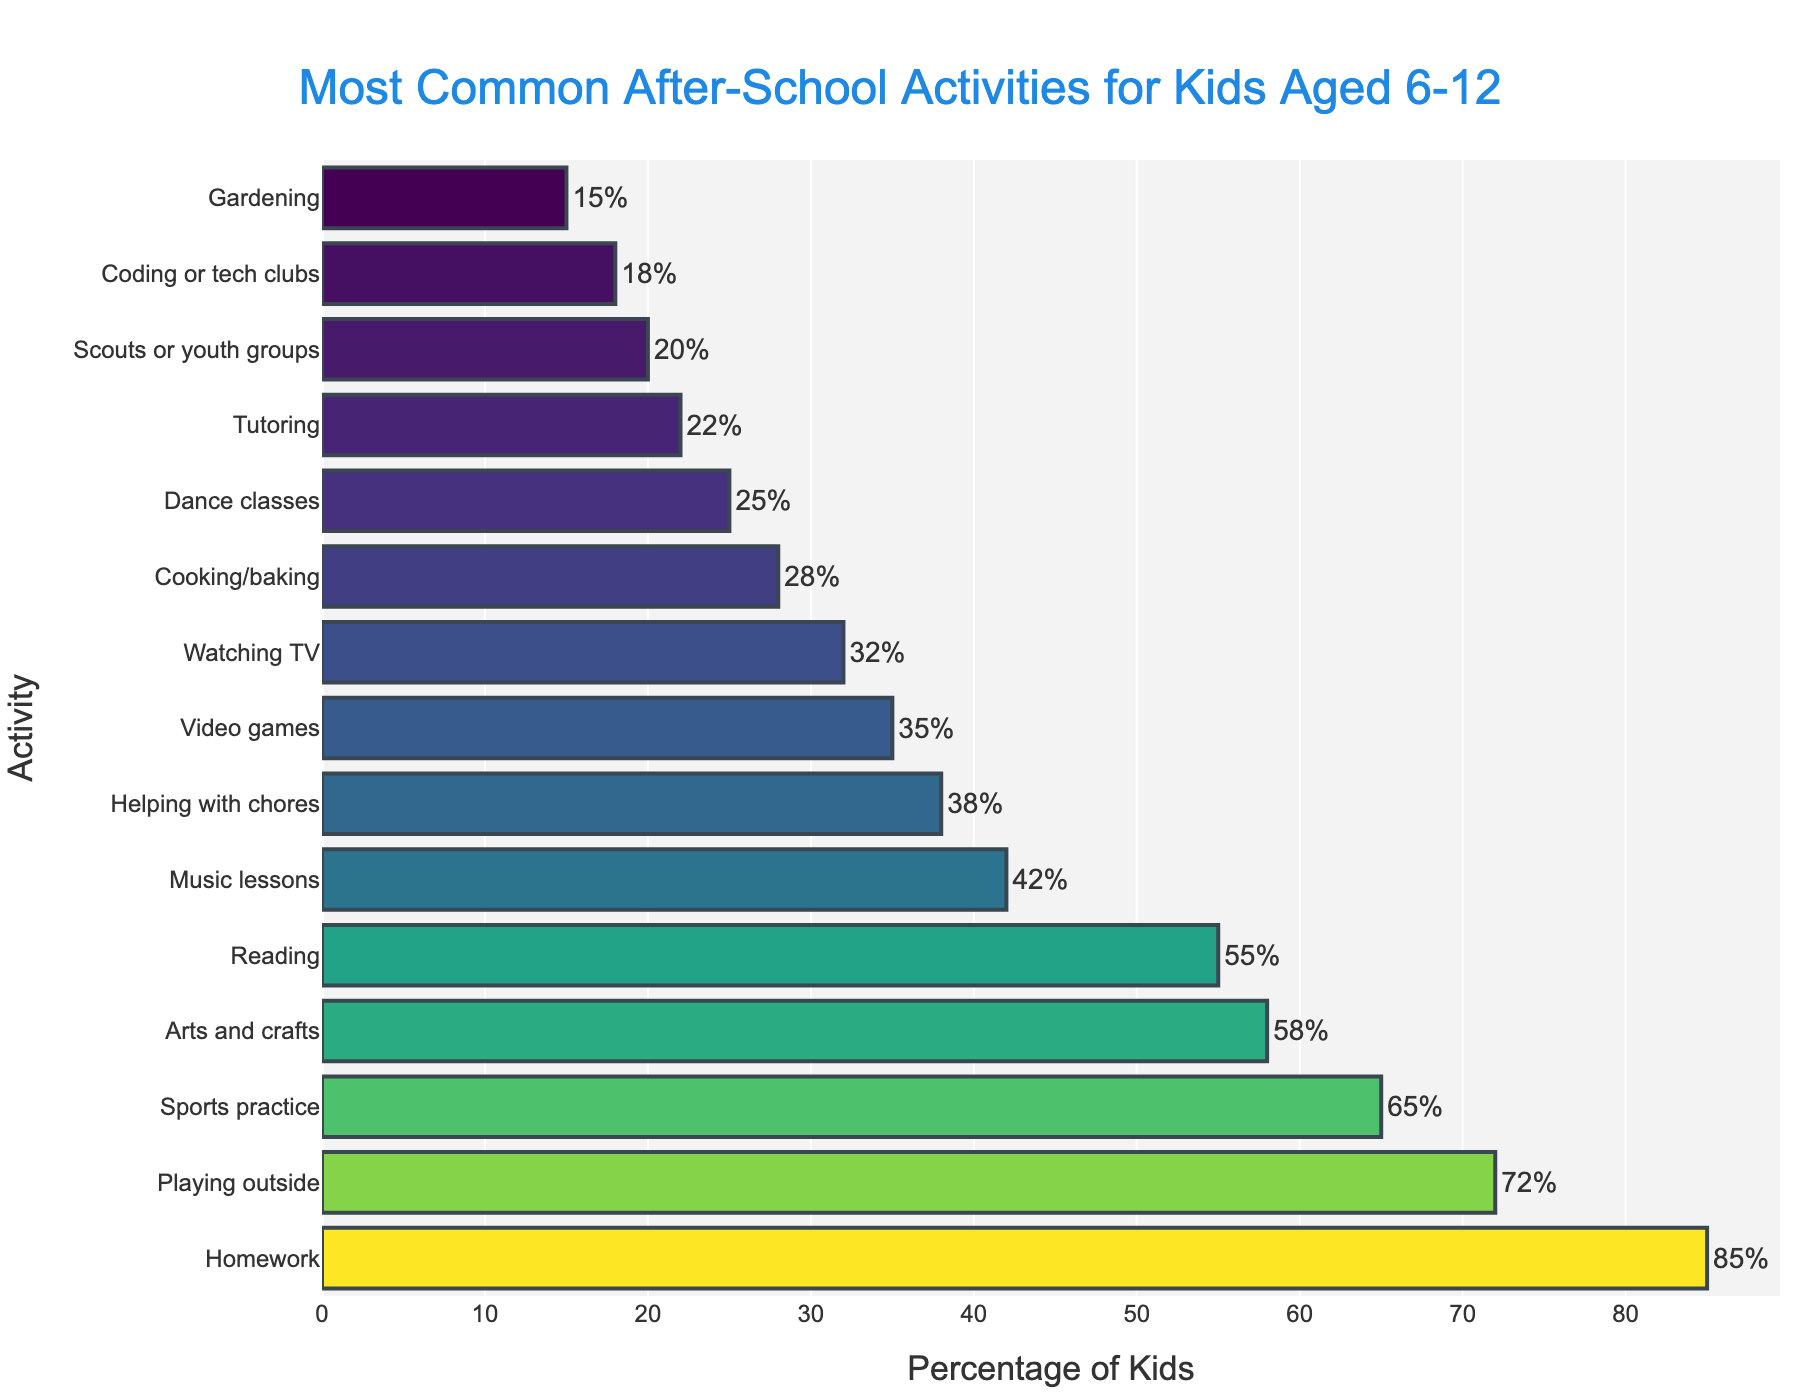What is the most common after-school activity for kids aged 6-12? Looking at the bar chart, the longest bar represents the most common activity. "Homework" has the longest bar with 85% participation.
Answer: Homework Which activity is more common, reading or music lessons? Compare the lengths of the bars for reading and music lessons. Reading has a bar with 55%, while music lessons have a bar with 42%. So, reading is more common.
Answer: Reading What is the difference in percentage between kids who play outside and those who play video games? Find the percentages for both activities: playing outside (72%) and video games (35%). Subtract video games from playing outside (72% - 35% = 37%).
Answer: 37% What is the total percentage of kids participating in gardening and scouts or youth groups combined? Identify the percentages for gardening (15%) and scouts or youth groups (20%). Add them together (15% + 20% = 35%).
Answer: 35% How many more kids help with chores compared to those who are in dance classes? Locate the percentages for both activities: helping with chores (38%) and dance classes (25%). Subtract the percentage for dance classes from that of helping with chores (38% - 25% = 13%).
Answer: 13% Which activities have less than 30% participation? Look at the bars with percentages lower than 30%: Cooking/baking (28%), Dance classes (25%), Tutoring (22%), Scouts or youth groups (20%), Coding or tech clubs (18%), and Gardening (15%).
Answer: Cooking/baking, Dance classes, Tutoring, Scouts or youth groups, Coding or tech clubs, Gardening By how much does participation in arts and crafts exceed that in cooking/baking? Identify the percentages for arts and crafts (58%) and cooking/baking (28%). Subtract cooking/baking from arts and crafts (58% - 28% = 30%).
Answer: 30% What is the average participation percentage for the three most common activities? Find the percentages for the three most common activities: Homework (85%), Playing outside (72%), and Sports practice (65%). Calculate the average: (85% + 72% + 65%) / 3 = 74%.
Answer: 74% What is the ratio of kids participating in sports practice to those participating in tutoring? Identify the percentages for sports practice (65%) and tutoring (22%). Divide the percentage for sports practice by that for tutoring (65% / 22% ≈ 2.95).
Answer: 2.95 What is the median percentage of participation across all listed activities? Arrange the percentages in ascending order: 15%, 18%, 20%, 22%, 25%, 28%, 32%, 35%, 38%, 42%, 55%, 58%, 65%, 72%, 85%. The middle value is the 8th one on the list, which is 35%.
Answer: 35% 